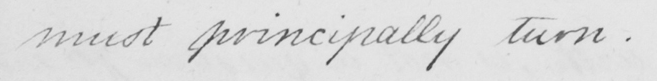Please provide the text content of this handwritten line. must principally turn . _ 